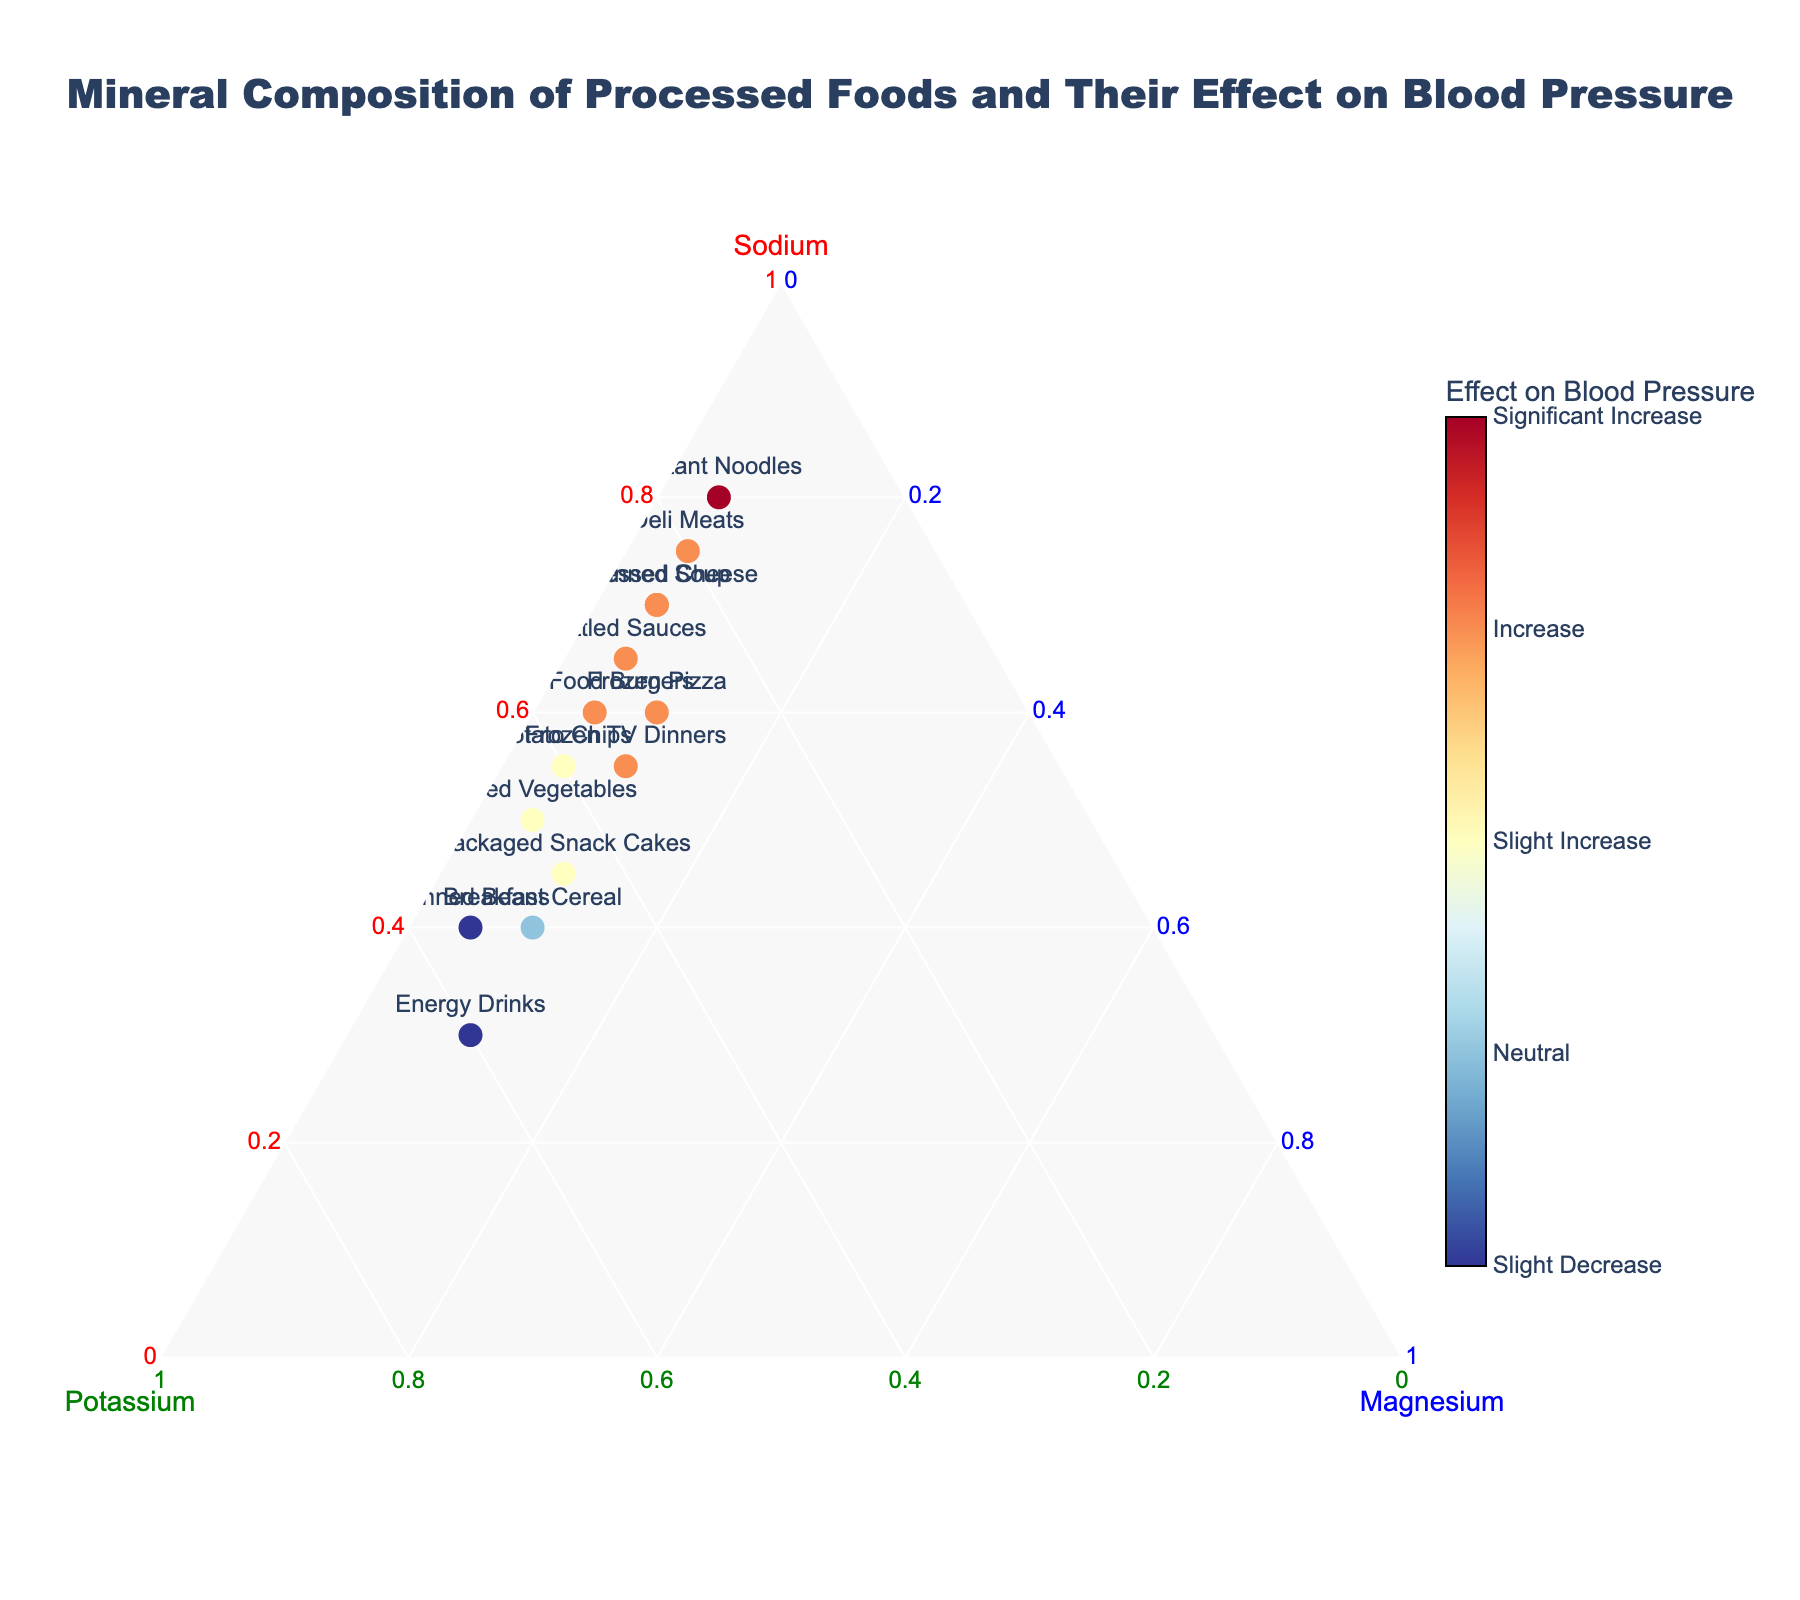What's the title of the figure? To find the title, look at the top of the figure. It should be prominently displayed.
Answer: Mineral Composition of Processed Foods and Their Effect on Blood Pressure What are the primary axis labels? The labels for the primary axes are usually displayed at the ends of the axes. In a ternary plot, you need to check the three corners of the plot.
Answer: Sodium, Potassium, Magnesium Which food item has the highest sodium content? To determine this, look for the data point closest to the corner labeled "Sodium" in the ternary plot.
Answer: Instant Noodles Are there any foods that have a neutral effect on blood pressure? To answer this, look at the color scale for the markers. Neutral effect is represented by the specific color at the 0 tick value. Find the marker(s) with this color.
Answer: Breakfast Cereal Which food item shows the greatest increase in blood pressure? Significant increases in blood pressure correspond to the highest value on the color scale (tick value 3). Look for the marker with this color.
Answer: Instant Noodles How many food items have a slight decrease in blood pressure? Refer to the color scale and the tick value that corresponds to a slight decrease (-1). Count the number of markers with this color.
Answer: 2 Which food items have the same ratio of potassium to magnesium content? Look for the data points on the ternary plot that have the same relative distances from the "Potassium" and "Magnesium" corners.
Answer: Packaged Snack Cakes and Canned Beans What is the combined percentage of Sodium and Magnesium for Frozen Pizza? Add the Sodium and Magnesium values for Frozen Pizza.
Answer: 0.60 + 0.10 = 0.70 Compare the sodium content between canned soup and canned vegetables. Which one is higher? Look at the coordinates for both "Canned Soup" and "Canned Vegetables" and compare their distances to the "Sodium" corner.
Answer: Canned Soup Which has a higher proportion of potassium: Energy Drinks or Fast Food Burgers? Compare the distances of "Energy Drinks" and "Fast Food Burgers" from the "Potassium" corner.
Answer: Energy Drinks 